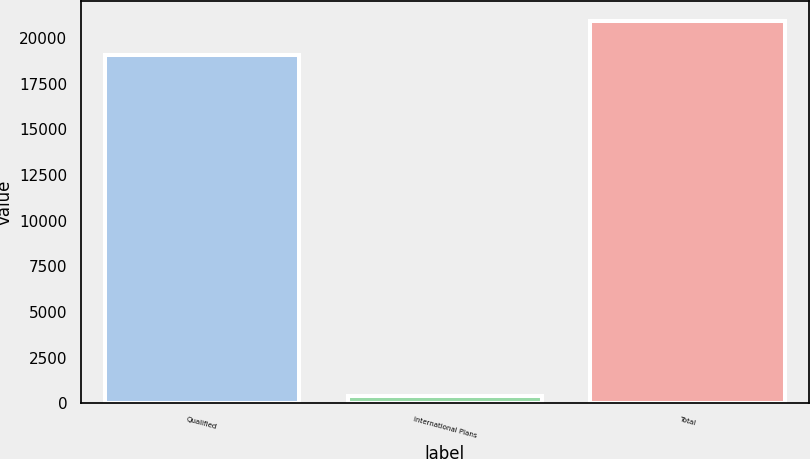<chart> <loc_0><loc_0><loc_500><loc_500><bar_chart><fcel>Qualified<fcel>International Plans<fcel>Total<nl><fcel>19047<fcel>386<fcel>20951.7<nl></chart> 